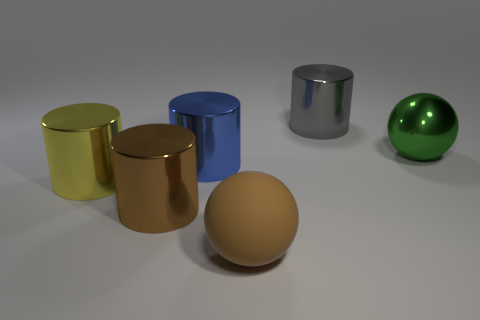There is a big green thing that is made of the same material as the yellow thing; what is its shape?
Your answer should be compact. Sphere. Are there any red matte cylinders?
Your answer should be compact. No. Is the number of green metallic things to the right of the yellow object less than the number of cylinders that are to the left of the rubber ball?
Make the answer very short. Yes. There is a big green metallic thing to the right of the brown ball; what shape is it?
Give a very brief answer. Sphere. Does the gray object have the same material as the large brown ball?
Your answer should be compact. No. Is there any other thing that has the same material as the large yellow cylinder?
Keep it short and to the point. Yes. There is another big thing that is the same shape as the green shiny object; what is it made of?
Keep it short and to the point. Rubber. Is the number of big yellow cylinders right of the big yellow shiny cylinder less than the number of tiny purple blocks?
Provide a succinct answer. No. There is a large brown metal thing; what number of things are in front of it?
Give a very brief answer. 1. Do the big shiny thing that is to the right of the gray cylinder and the big brown thing that is right of the big blue metallic cylinder have the same shape?
Keep it short and to the point. Yes. 